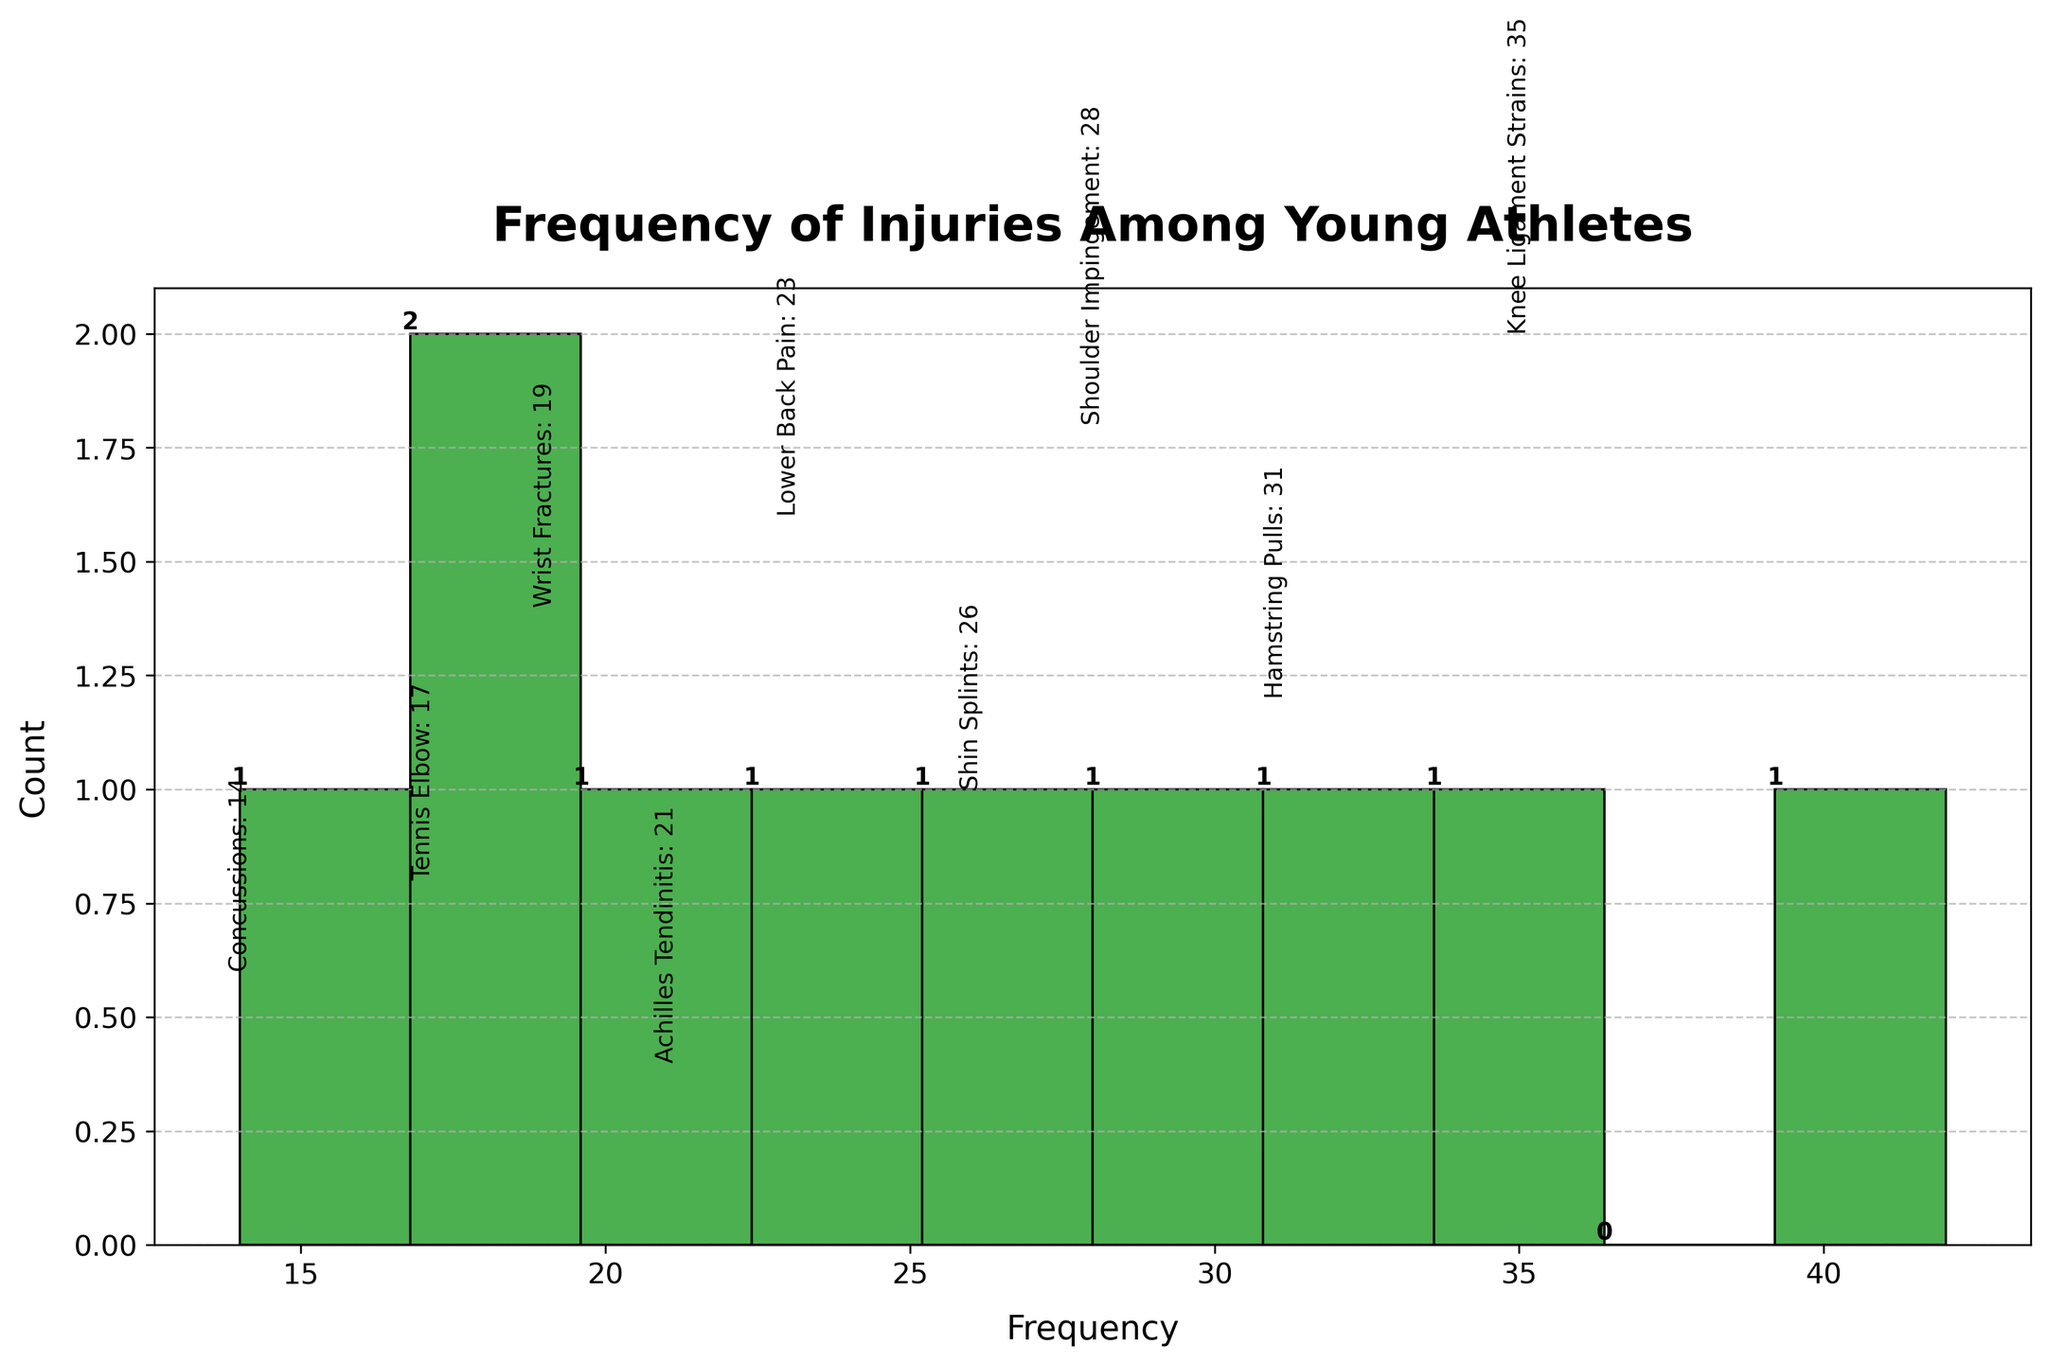What's the title of the figure? The title is displayed at the top of the figure in a bold and prominent font. It reads "Frequency of Injuries Among Young Athletes".
Answer: Frequency of Injuries Among Young Athletes How many distinct types of injuries are presented in the figure? The histogram contains individual bars for each type of injury, with frequency annotations for clarity. There are 10 distinct types of injuries indicated.
Answer: 10 Which injury has the highest frequency? By observing the height of the bars and the frequency labels, the tallest bar corresponds to "Ankle Sprains" with a frequency of 42.
Answer: Ankle Sprains What is the frequency of knee ligament strains compared to shoulder impingement? The frequency of Knee Ligament Strains is 35 and Shoulder Impingement is 28, showing Knee Ligament Strains are more frequent.
Answer: Knee Ligament Strains What is the median frequency of the injuries listed? To find the median, first sort the frequencies: [14, 17, 19, 21, 23, 26, 28, 31, 35, 42]. The median of these 10 values is the average of the 5th and 6th values (23 and 26), so (23+26)/2 = 24.5.
Answer: 24.5 Which injury is less frequent, concussions or tennis elbow? The frequency annotations indicate Concussions have a frequency of 14 and Tennis Elbow has a frequency of 17, making Concussions less frequent.
Answer: Concussions How many injuries are there with a frequency greater than 25 but less than 40? By checking the frequencies, those within this range are Knee Ligament Strains (35), Hamstring Pulls (31), and Shoulder Impingement (28). There are 3 such injuries.
Answer: 3 What is the difference in frequency between the most and least common injuries? The most common injury (Ankle Sprains) has a frequency of 42, and the least common injury (Concussions) has 14. The difference is 42 - 14 = 28.
Answer: 28 Which two injuries have the closest frequencies to each other? By comparing the frequencies, Achilles Tendinitis (21) and Lower Back Pain (23) are the closest, with a difference of 23 - 21 = 2.
Answer: Achilles Tendinitis and Lower Back Pain What range of frequencies is most represented on the histogram, and how many injuries fall in that range? The histogram's most populated frequency range is 20-30, covering Lower Back Pain (23), Shoulder Impingement (28), Shin Splints (26), Hamstring Pulls (31), and Achilles Tendinitis (21), totaling to 5 injuries.
Answer: 20-30, 5 injuries 